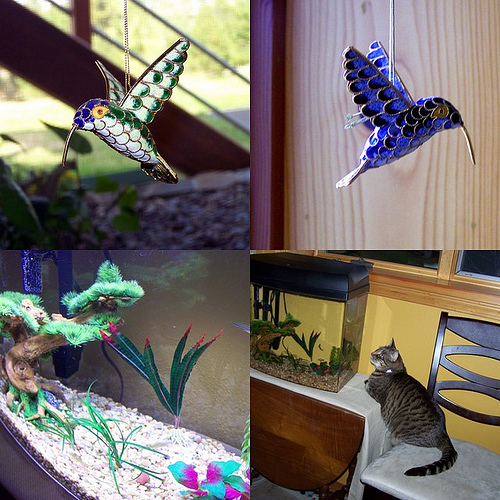Considering the decor of the aquariums, what type of environment are they aiming to replicate? The decor within the two aquariums in the bottom images seems to replicate a simplified, somewhat stylized version of an aquatic habitat. The use of colorful gravel, artificial plants, and decorative treasures like the pirate skeleton aims to create a visually appealing environment for both the fish and the observer. It lacks the complexity of a natural ecosystem, but such decorations are commonly enjoyed in home aquariums for their ease of maintenance and cheerful appearance. 